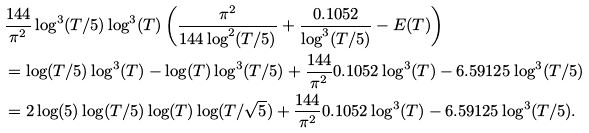<formula> <loc_0><loc_0><loc_500><loc_500>& \frac { 1 4 4 } { \pi ^ { 2 } } \log ^ { 3 } ( T / 5 ) \log ^ { 3 } ( T ) \left ( \frac { \pi ^ { 2 } } { 1 4 4 \log ^ { 2 } ( T / 5 ) } + \frac { 0 . 1 0 5 2 } { \log ^ { 3 } ( T / 5 ) } - E ( T ) \right ) \\ & = \log ( T / 5 ) \log ^ { 3 } ( T ) - \log ( T ) \log ^ { 3 } ( T / 5 ) + \frac { 1 4 4 } { \pi ^ { 2 } } 0 . 1 0 5 2 \log ^ { 3 } ( T ) - 6 . 5 9 1 2 5 \log ^ { 3 } ( T / 5 ) \\ & = 2 \log ( 5 ) \log ( T / 5 ) \log ( T ) \log ( T / \sqrt { 5 } ) + \frac { 1 4 4 } { \pi ^ { 2 } } 0 . 1 0 5 2 \log ^ { 3 } ( T ) - 6 . 5 9 1 2 5 \log ^ { 3 } ( T / 5 ) .</formula> 